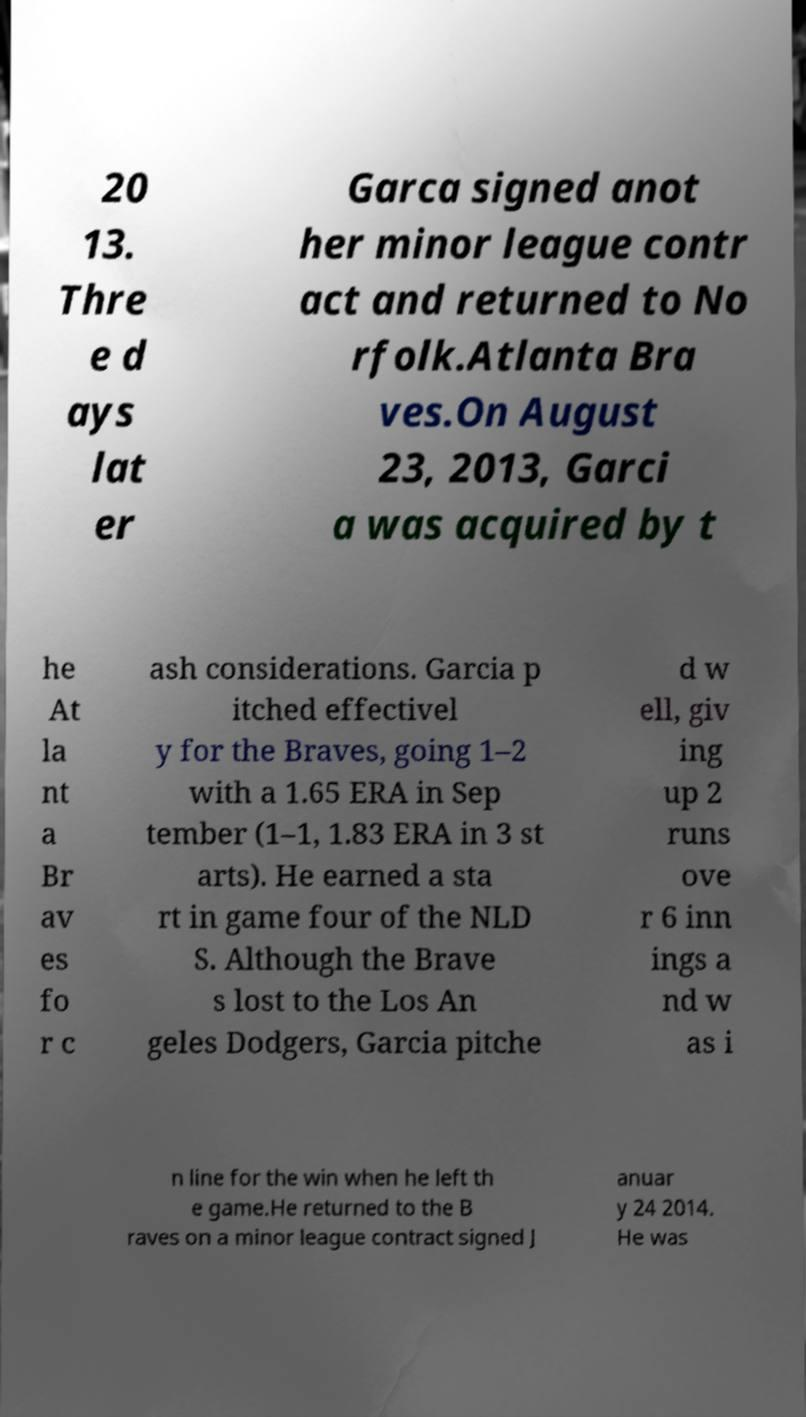Could you extract and type out the text from this image? 20 13. Thre e d ays lat er Garca signed anot her minor league contr act and returned to No rfolk.Atlanta Bra ves.On August 23, 2013, Garci a was acquired by t he At la nt a Br av es fo r c ash considerations. Garcia p itched effectivel y for the Braves, going 1–2 with a 1.65 ERA in Sep tember (1–1, 1.83 ERA in 3 st arts). He earned a sta rt in game four of the NLD S. Although the Brave s lost to the Los An geles Dodgers, Garcia pitche d w ell, giv ing up 2 runs ove r 6 inn ings a nd w as i n line for the win when he left th e game.He returned to the B raves on a minor league contract signed J anuar y 24 2014. He was 